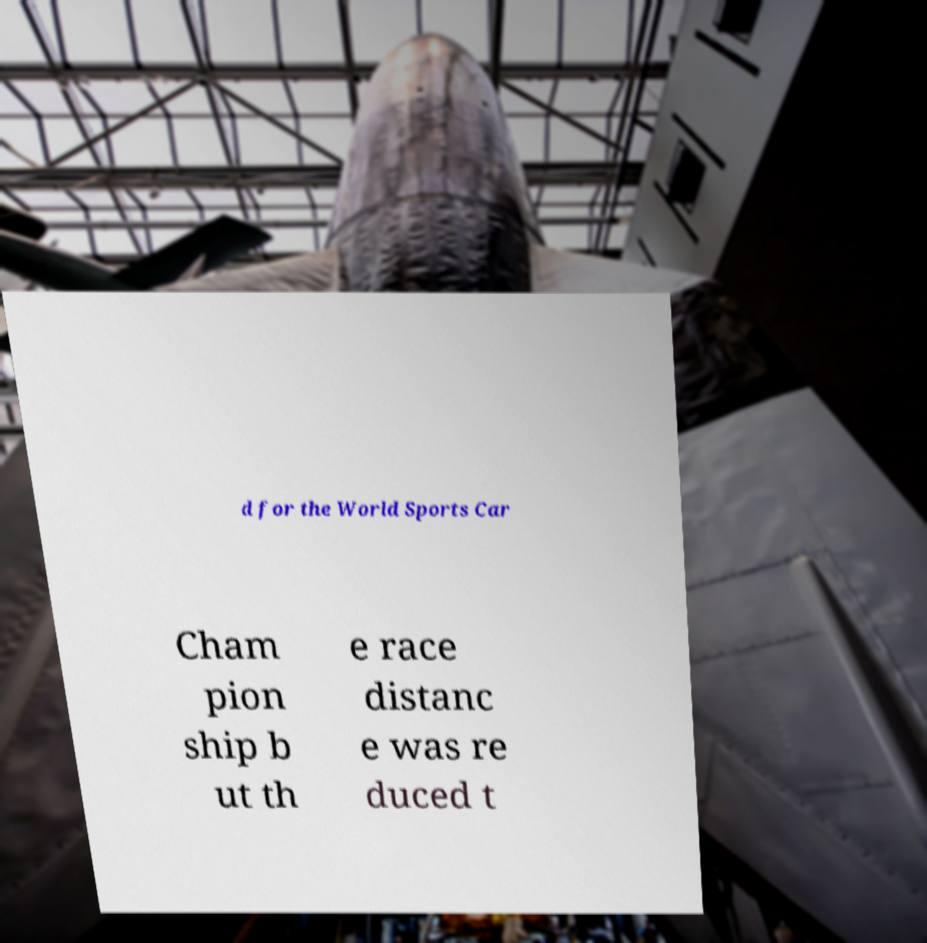Please read and relay the text visible in this image. What does it say? d for the World Sports Car Cham pion ship b ut th e race distanc e was re duced t 